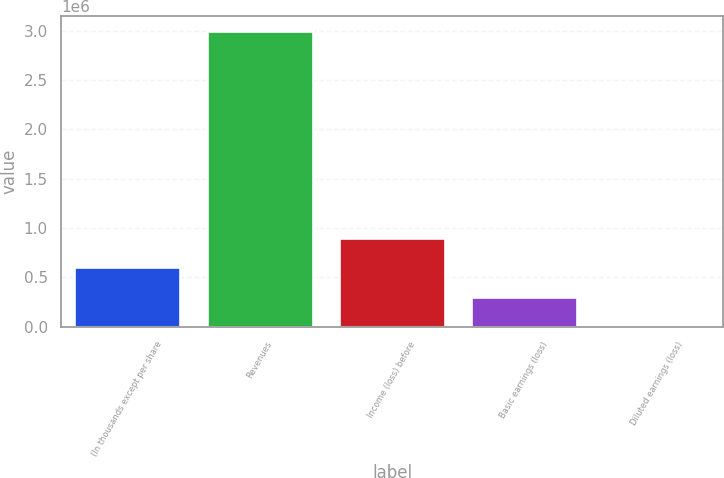<chart> <loc_0><loc_0><loc_500><loc_500><bar_chart><fcel>(In thousands except per share<fcel>Revenues<fcel>Income (loss) before<fcel>Basic earnings (loss)<fcel>Diluted earnings (loss)<nl><fcel>600040<fcel>3.0002e+06<fcel>900060<fcel>300021<fcel>1.21<nl></chart> 